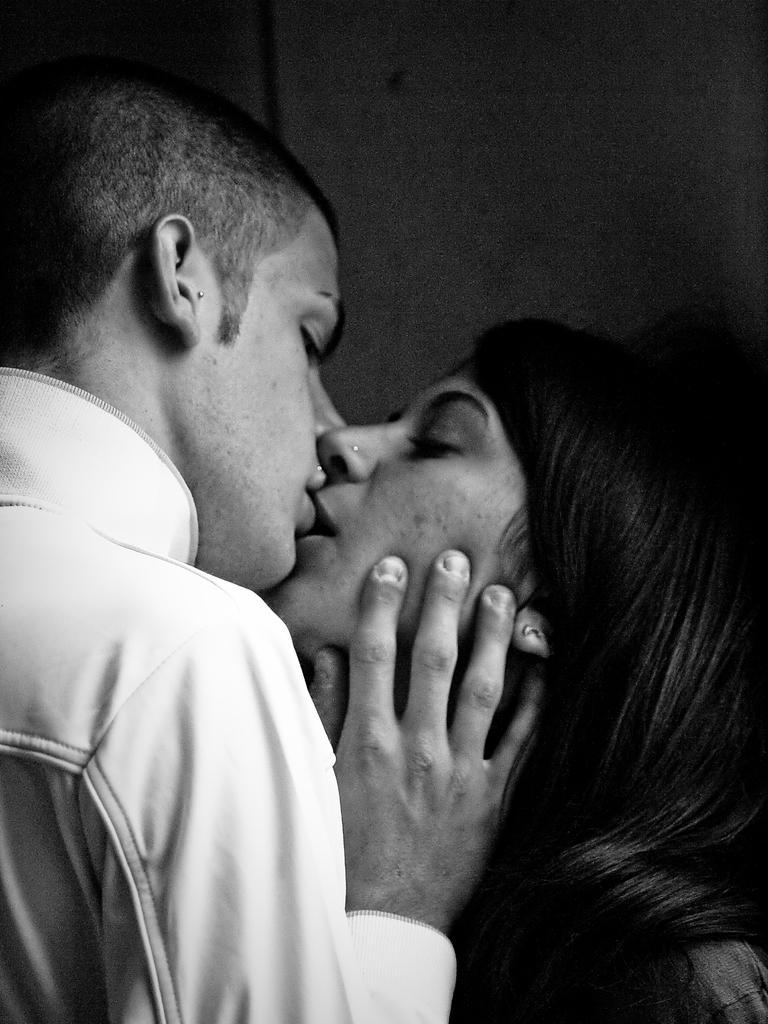How would you summarize this image in a sentence or two? This is a black and white picture. In this picture we can see a couple kissing. At the top it is well. 